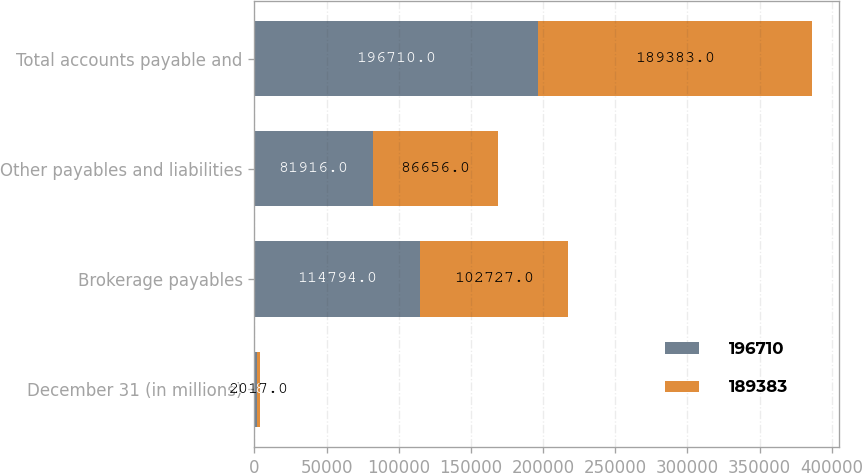Convert chart to OTSL. <chart><loc_0><loc_0><loc_500><loc_500><stacked_bar_chart><ecel><fcel>December 31 (in millions)<fcel>Brokerage payables<fcel>Other payables and liabilities<fcel>Total accounts payable and<nl><fcel>196710<fcel>2018<fcel>114794<fcel>81916<fcel>196710<nl><fcel>189383<fcel>2017<fcel>102727<fcel>86656<fcel>189383<nl></chart> 